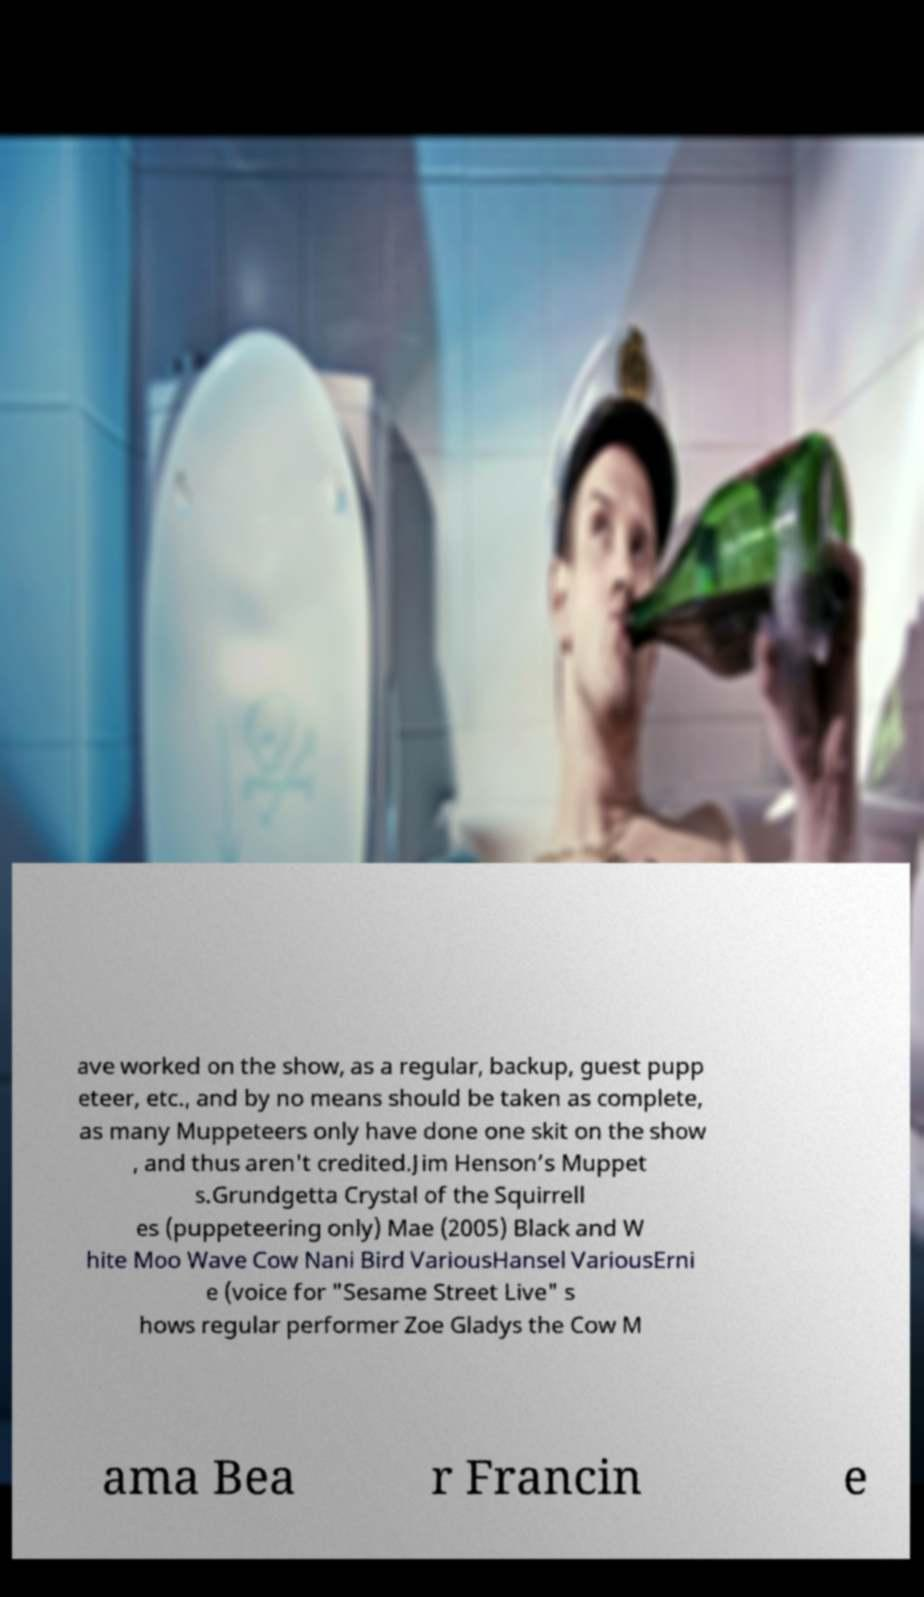Could you extract and type out the text from this image? ave worked on the show, as a regular, backup, guest pupp eteer, etc., and by no means should be taken as complete, as many Muppeteers only have done one skit on the show , and thus aren't credited.Jim Henson’s Muppet s.Grundgetta Crystal of the Squirrell es (puppeteering only) Mae (2005) Black and W hite Moo Wave Cow Nani Bird VariousHansel VariousErni e (voice for "Sesame Street Live" s hows regular performer Zoe Gladys the Cow M ama Bea r Francin e 